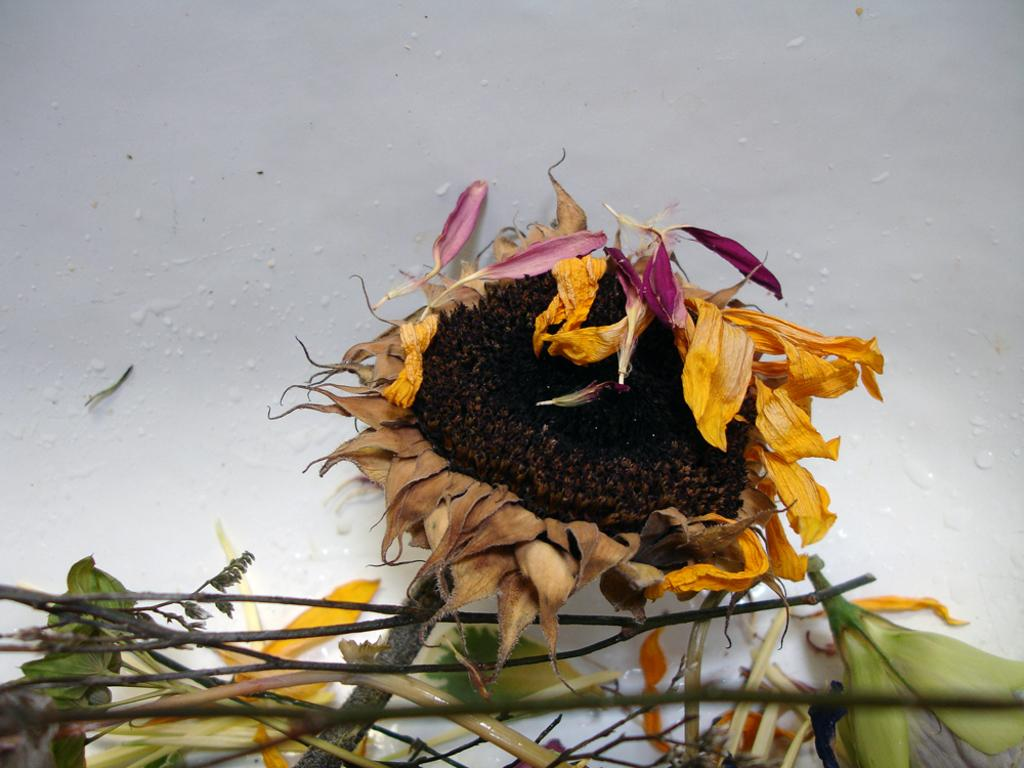What is the main subject in the middle of the image? There is a flower in the middle of the image. What can be seen at the bottom of the image? There are stems of plants at the bottom of the image. How deep is the ocean in the image? There is no ocean present in the image; it features a flower and stems of plants. What type of riddle can be solved using the image? The image does not contain any elements that would allow for solving a riddle. 